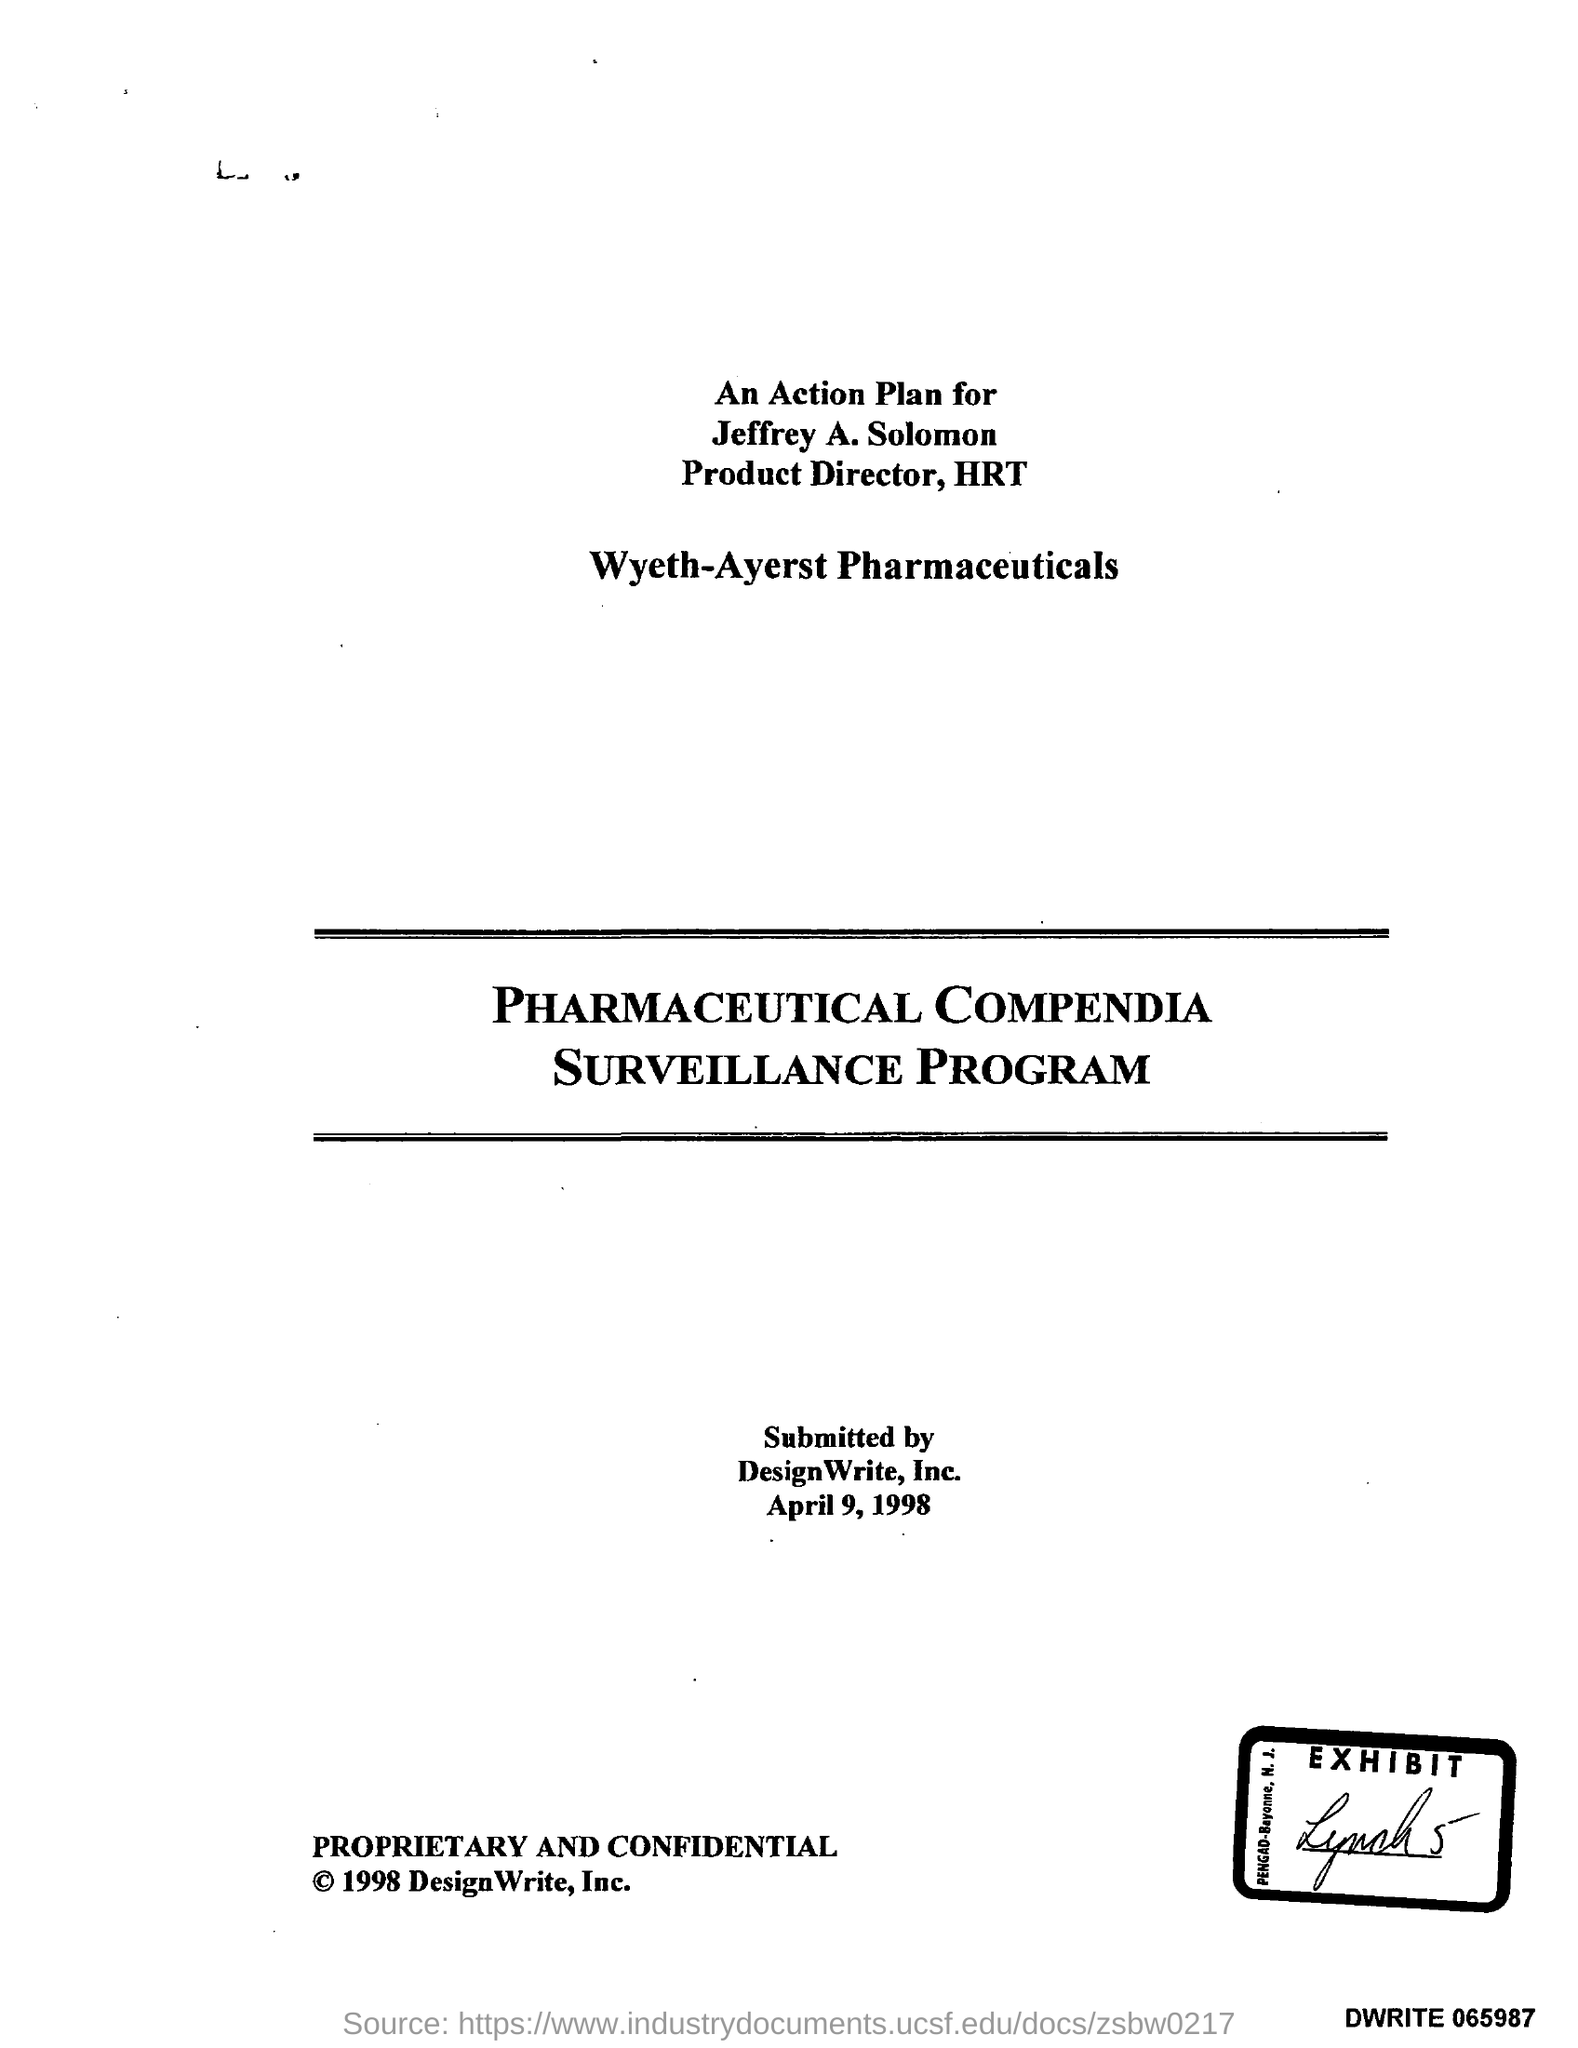Outline some significant characteristics in this image. Jeffrey A. Solomon is the Product Director of HRT. The document contains the date of April 9, 1998. 